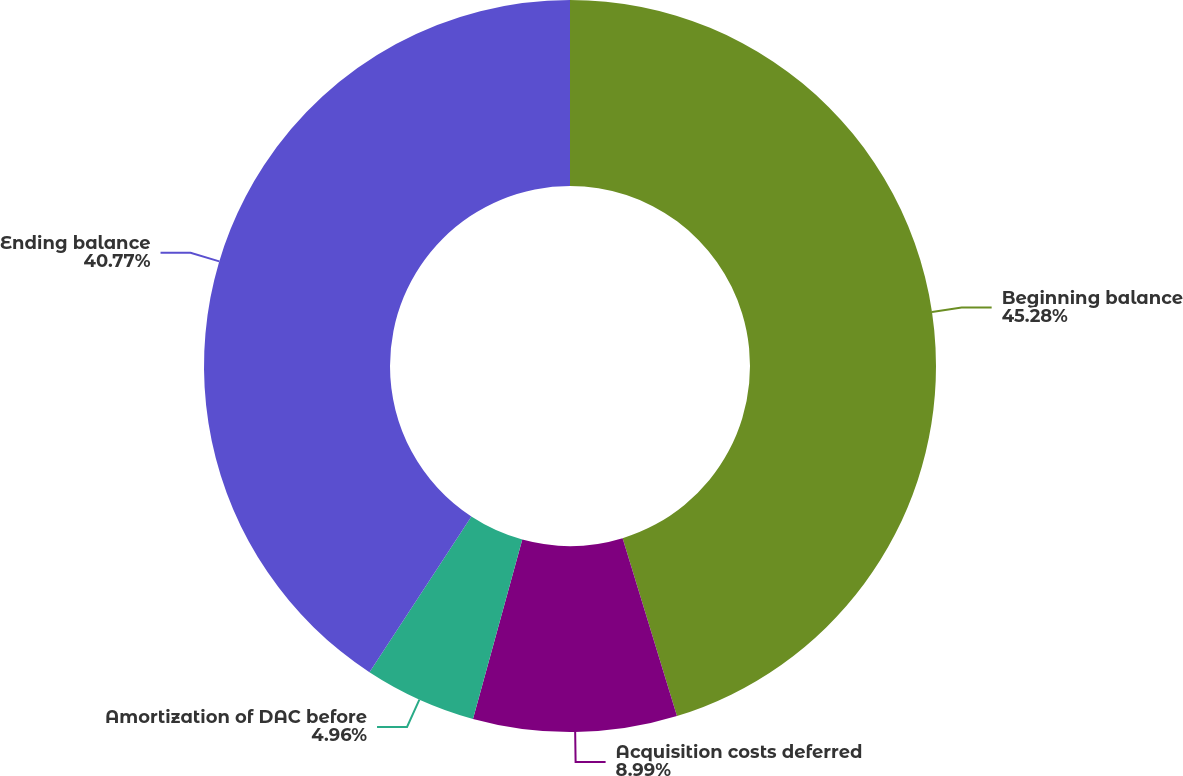Convert chart to OTSL. <chart><loc_0><loc_0><loc_500><loc_500><pie_chart><fcel>Beginning balance<fcel>Acquisition costs deferred<fcel>Amortization of DAC before<fcel>Ending balance<nl><fcel>45.28%<fcel>8.99%<fcel>4.96%<fcel>40.77%<nl></chart> 